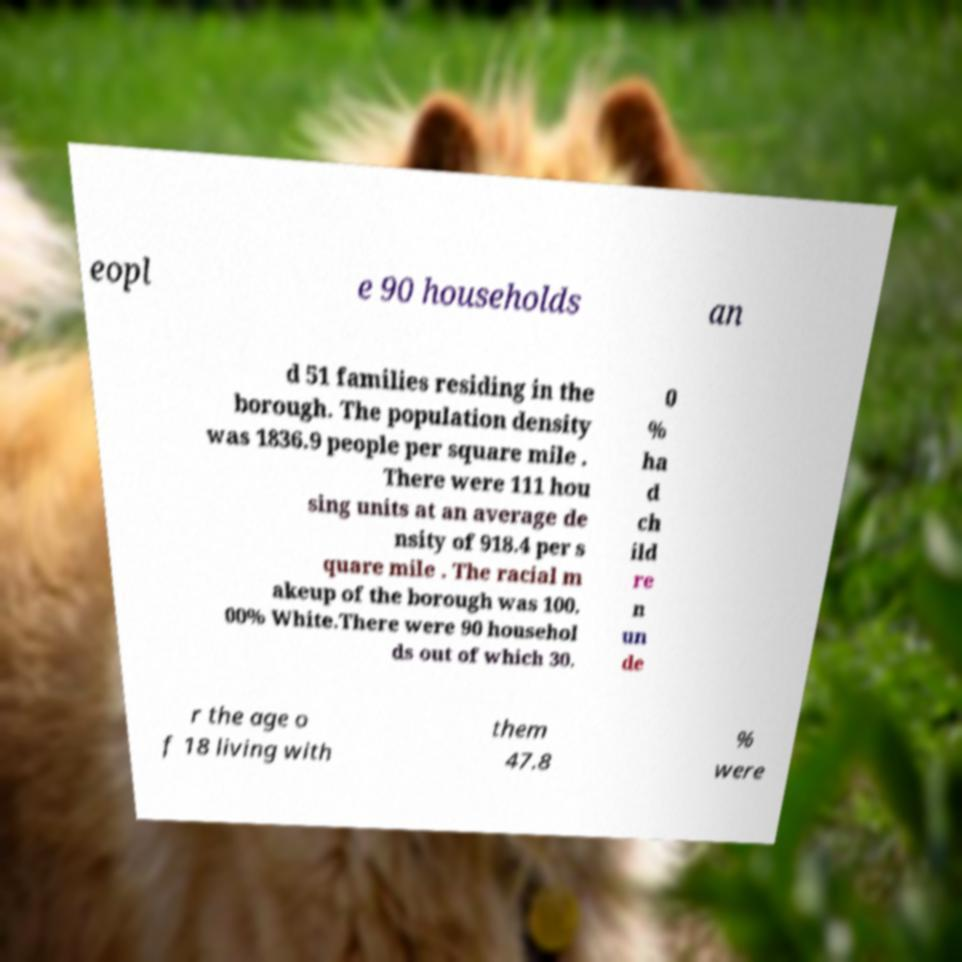Could you assist in decoding the text presented in this image and type it out clearly? eopl e 90 households an d 51 families residing in the borough. The population density was 1836.9 people per square mile . There were 111 hou sing units at an average de nsity of 918.4 per s quare mile . The racial m akeup of the borough was 100. 00% White.There were 90 househol ds out of which 30. 0 % ha d ch ild re n un de r the age o f 18 living with them 47.8 % were 